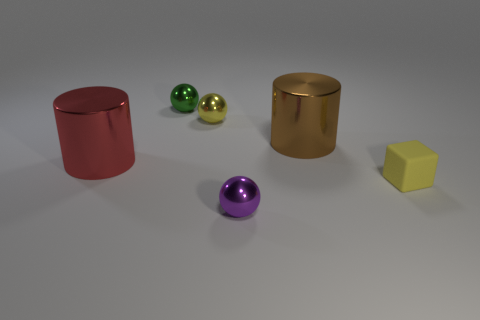Are there more small yellow spheres that are in front of the brown metallic cylinder than tiny objects that are on the right side of the tiny yellow sphere?
Provide a succinct answer. No. Does the cylinder that is in front of the large brown shiny thing have the same color as the block?
Keep it short and to the point. No. Are there any other things that have the same color as the matte cube?
Provide a short and direct response. Yes. Is the number of green things in front of the small matte block greater than the number of yellow shiny balls?
Make the answer very short. No. Do the purple metal sphere and the yellow matte thing have the same size?
Offer a very short reply. Yes. There is another object that is the same shape as the brown metal thing; what material is it?
Offer a terse response. Metal. Is there anything else that is the same material as the yellow block?
Provide a short and direct response. No. What number of yellow things are either tiny metallic objects or small cubes?
Your response must be concise. 2. What is the material of the tiny thing to the right of the big brown cylinder?
Offer a very short reply. Rubber. Is the number of large cylinders greater than the number of metallic things?
Ensure brevity in your answer.  No. 